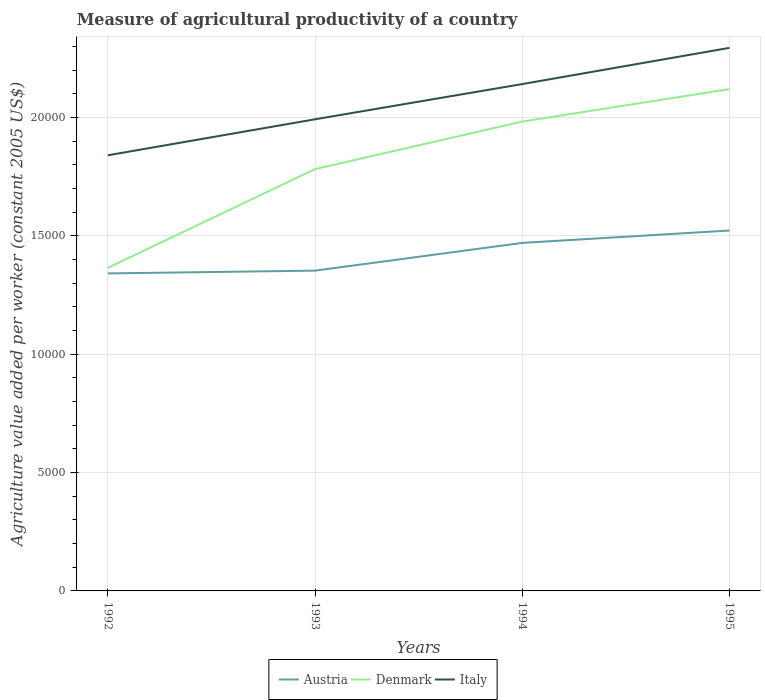Across all years, what is the maximum measure of agricultural productivity in Denmark?
Provide a short and direct response. 1.37e+04. What is the total measure of agricultural productivity in Denmark in the graph?
Provide a short and direct response. -7550.25. What is the difference between the highest and the second highest measure of agricultural productivity in Austria?
Your answer should be very brief. 1812.25. Is the measure of agricultural productivity in Italy strictly greater than the measure of agricultural productivity in Denmark over the years?
Make the answer very short. No. What is the difference between two consecutive major ticks on the Y-axis?
Provide a short and direct response. 5000. Are the values on the major ticks of Y-axis written in scientific E-notation?
Your answer should be compact. No. What is the title of the graph?
Provide a short and direct response. Measure of agricultural productivity of a country. Does "St. Vincent and the Grenadines" appear as one of the legend labels in the graph?
Your answer should be compact. No. What is the label or title of the Y-axis?
Your response must be concise. Agriculture value added per worker (constant 2005 US$). What is the Agriculture value added per worker (constant 2005 US$) of Austria in 1992?
Give a very brief answer. 1.34e+04. What is the Agriculture value added per worker (constant 2005 US$) in Denmark in 1992?
Make the answer very short. 1.37e+04. What is the Agriculture value added per worker (constant 2005 US$) in Italy in 1992?
Make the answer very short. 1.84e+04. What is the Agriculture value added per worker (constant 2005 US$) of Austria in 1993?
Offer a terse response. 1.35e+04. What is the Agriculture value added per worker (constant 2005 US$) in Denmark in 1993?
Ensure brevity in your answer.  1.78e+04. What is the Agriculture value added per worker (constant 2005 US$) of Italy in 1993?
Keep it short and to the point. 1.99e+04. What is the Agriculture value added per worker (constant 2005 US$) in Austria in 1994?
Your answer should be very brief. 1.47e+04. What is the Agriculture value added per worker (constant 2005 US$) of Denmark in 1994?
Your answer should be compact. 1.98e+04. What is the Agriculture value added per worker (constant 2005 US$) in Italy in 1994?
Your answer should be compact. 2.14e+04. What is the Agriculture value added per worker (constant 2005 US$) of Austria in 1995?
Make the answer very short. 1.52e+04. What is the Agriculture value added per worker (constant 2005 US$) in Denmark in 1995?
Make the answer very short. 2.12e+04. What is the Agriculture value added per worker (constant 2005 US$) of Italy in 1995?
Give a very brief answer. 2.29e+04. Across all years, what is the maximum Agriculture value added per worker (constant 2005 US$) of Austria?
Give a very brief answer. 1.52e+04. Across all years, what is the maximum Agriculture value added per worker (constant 2005 US$) of Denmark?
Your answer should be very brief. 2.12e+04. Across all years, what is the maximum Agriculture value added per worker (constant 2005 US$) in Italy?
Provide a short and direct response. 2.29e+04. Across all years, what is the minimum Agriculture value added per worker (constant 2005 US$) in Austria?
Your answer should be compact. 1.34e+04. Across all years, what is the minimum Agriculture value added per worker (constant 2005 US$) in Denmark?
Your answer should be very brief. 1.37e+04. Across all years, what is the minimum Agriculture value added per worker (constant 2005 US$) of Italy?
Ensure brevity in your answer.  1.84e+04. What is the total Agriculture value added per worker (constant 2005 US$) of Austria in the graph?
Keep it short and to the point. 5.69e+04. What is the total Agriculture value added per worker (constant 2005 US$) of Denmark in the graph?
Provide a succinct answer. 7.25e+04. What is the total Agriculture value added per worker (constant 2005 US$) in Italy in the graph?
Make the answer very short. 8.27e+04. What is the difference between the Agriculture value added per worker (constant 2005 US$) in Austria in 1992 and that in 1993?
Offer a very short reply. -117.39. What is the difference between the Agriculture value added per worker (constant 2005 US$) of Denmark in 1992 and that in 1993?
Offer a terse response. -4170.25. What is the difference between the Agriculture value added per worker (constant 2005 US$) in Italy in 1992 and that in 1993?
Provide a succinct answer. -1521.49. What is the difference between the Agriculture value added per worker (constant 2005 US$) of Austria in 1992 and that in 1994?
Your response must be concise. -1288.85. What is the difference between the Agriculture value added per worker (constant 2005 US$) in Denmark in 1992 and that in 1994?
Your answer should be very brief. -6179.53. What is the difference between the Agriculture value added per worker (constant 2005 US$) in Italy in 1992 and that in 1994?
Ensure brevity in your answer.  -3008.88. What is the difference between the Agriculture value added per worker (constant 2005 US$) of Austria in 1992 and that in 1995?
Offer a very short reply. -1812.25. What is the difference between the Agriculture value added per worker (constant 2005 US$) in Denmark in 1992 and that in 1995?
Your answer should be compact. -7550.25. What is the difference between the Agriculture value added per worker (constant 2005 US$) of Italy in 1992 and that in 1995?
Give a very brief answer. -4539.28. What is the difference between the Agriculture value added per worker (constant 2005 US$) of Austria in 1993 and that in 1994?
Your answer should be very brief. -1171.46. What is the difference between the Agriculture value added per worker (constant 2005 US$) in Denmark in 1993 and that in 1994?
Your response must be concise. -2009.28. What is the difference between the Agriculture value added per worker (constant 2005 US$) of Italy in 1993 and that in 1994?
Offer a terse response. -1487.39. What is the difference between the Agriculture value added per worker (constant 2005 US$) of Austria in 1993 and that in 1995?
Your answer should be very brief. -1694.85. What is the difference between the Agriculture value added per worker (constant 2005 US$) in Denmark in 1993 and that in 1995?
Your answer should be very brief. -3380. What is the difference between the Agriculture value added per worker (constant 2005 US$) of Italy in 1993 and that in 1995?
Ensure brevity in your answer.  -3017.79. What is the difference between the Agriculture value added per worker (constant 2005 US$) of Austria in 1994 and that in 1995?
Your answer should be compact. -523.4. What is the difference between the Agriculture value added per worker (constant 2005 US$) of Denmark in 1994 and that in 1995?
Your answer should be very brief. -1370.72. What is the difference between the Agriculture value added per worker (constant 2005 US$) of Italy in 1994 and that in 1995?
Offer a terse response. -1530.4. What is the difference between the Agriculture value added per worker (constant 2005 US$) of Austria in 1992 and the Agriculture value added per worker (constant 2005 US$) of Denmark in 1993?
Your answer should be compact. -4406.2. What is the difference between the Agriculture value added per worker (constant 2005 US$) in Austria in 1992 and the Agriculture value added per worker (constant 2005 US$) in Italy in 1993?
Your response must be concise. -6511.72. What is the difference between the Agriculture value added per worker (constant 2005 US$) of Denmark in 1992 and the Agriculture value added per worker (constant 2005 US$) of Italy in 1993?
Provide a short and direct response. -6275.76. What is the difference between the Agriculture value added per worker (constant 2005 US$) of Austria in 1992 and the Agriculture value added per worker (constant 2005 US$) of Denmark in 1994?
Give a very brief answer. -6415.49. What is the difference between the Agriculture value added per worker (constant 2005 US$) in Austria in 1992 and the Agriculture value added per worker (constant 2005 US$) in Italy in 1994?
Keep it short and to the point. -7999.11. What is the difference between the Agriculture value added per worker (constant 2005 US$) in Denmark in 1992 and the Agriculture value added per worker (constant 2005 US$) in Italy in 1994?
Keep it short and to the point. -7763.15. What is the difference between the Agriculture value added per worker (constant 2005 US$) of Austria in 1992 and the Agriculture value added per worker (constant 2005 US$) of Denmark in 1995?
Your answer should be compact. -7786.2. What is the difference between the Agriculture value added per worker (constant 2005 US$) of Austria in 1992 and the Agriculture value added per worker (constant 2005 US$) of Italy in 1995?
Keep it short and to the point. -9529.51. What is the difference between the Agriculture value added per worker (constant 2005 US$) of Denmark in 1992 and the Agriculture value added per worker (constant 2005 US$) of Italy in 1995?
Your answer should be compact. -9293.56. What is the difference between the Agriculture value added per worker (constant 2005 US$) in Austria in 1993 and the Agriculture value added per worker (constant 2005 US$) in Denmark in 1994?
Your answer should be compact. -6298.09. What is the difference between the Agriculture value added per worker (constant 2005 US$) in Austria in 1993 and the Agriculture value added per worker (constant 2005 US$) in Italy in 1994?
Offer a very short reply. -7881.72. What is the difference between the Agriculture value added per worker (constant 2005 US$) in Denmark in 1993 and the Agriculture value added per worker (constant 2005 US$) in Italy in 1994?
Your answer should be very brief. -3592.91. What is the difference between the Agriculture value added per worker (constant 2005 US$) in Austria in 1993 and the Agriculture value added per worker (constant 2005 US$) in Denmark in 1995?
Offer a very short reply. -7668.81. What is the difference between the Agriculture value added per worker (constant 2005 US$) in Austria in 1993 and the Agriculture value added per worker (constant 2005 US$) in Italy in 1995?
Provide a short and direct response. -9412.12. What is the difference between the Agriculture value added per worker (constant 2005 US$) of Denmark in 1993 and the Agriculture value added per worker (constant 2005 US$) of Italy in 1995?
Ensure brevity in your answer.  -5123.31. What is the difference between the Agriculture value added per worker (constant 2005 US$) in Austria in 1994 and the Agriculture value added per worker (constant 2005 US$) in Denmark in 1995?
Your response must be concise. -6497.35. What is the difference between the Agriculture value added per worker (constant 2005 US$) of Austria in 1994 and the Agriculture value added per worker (constant 2005 US$) of Italy in 1995?
Your response must be concise. -8240.66. What is the difference between the Agriculture value added per worker (constant 2005 US$) in Denmark in 1994 and the Agriculture value added per worker (constant 2005 US$) in Italy in 1995?
Make the answer very short. -3114.03. What is the average Agriculture value added per worker (constant 2005 US$) of Austria per year?
Give a very brief answer. 1.42e+04. What is the average Agriculture value added per worker (constant 2005 US$) in Denmark per year?
Provide a succinct answer. 1.81e+04. What is the average Agriculture value added per worker (constant 2005 US$) of Italy per year?
Keep it short and to the point. 2.07e+04. In the year 1992, what is the difference between the Agriculture value added per worker (constant 2005 US$) of Austria and Agriculture value added per worker (constant 2005 US$) of Denmark?
Ensure brevity in your answer.  -235.95. In the year 1992, what is the difference between the Agriculture value added per worker (constant 2005 US$) in Austria and Agriculture value added per worker (constant 2005 US$) in Italy?
Offer a very short reply. -4990.23. In the year 1992, what is the difference between the Agriculture value added per worker (constant 2005 US$) in Denmark and Agriculture value added per worker (constant 2005 US$) in Italy?
Your response must be concise. -4754.28. In the year 1993, what is the difference between the Agriculture value added per worker (constant 2005 US$) in Austria and Agriculture value added per worker (constant 2005 US$) in Denmark?
Ensure brevity in your answer.  -4288.81. In the year 1993, what is the difference between the Agriculture value added per worker (constant 2005 US$) in Austria and Agriculture value added per worker (constant 2005 US$) in Italy?
Your response must be concise. -6394.32. In the year 1993, what is the difference between the Agriculture value added per worker (constant 2005 US$) of Denmark and Agriculture value added per worker (constant 2005 US$) of Italy?
Your answer should be very brief. -2105.51. In the year 1994, what is the difference between the Agriculture value added per worker (constant 2005 US$) of Austria and Agriculture value added per worker (constant 2005 US$) of Denmark?
Give a very brief answer. -5126.64. In the year 1994, what is the difference between the Agriculture value added per worker (constant 2005 US$) of Austria and Agriculture value added per worker (constant 2005 US$) of Italy?
Your answer should be very brief. -6710.26. In the year 1994, what is the difference between the Agriculture value added per worker (constant 2005 US$) of Denmark and Agriculture value added per worker (constant 2005 US$) of Italy?
Provide a succinct answer. -1583.62. In the year 1995, what is the difference between the Agriculture value added per worker (constant 2005 US$) in Austria and Agriculture value added per worker (constant 2005 US$) in Denmark?
Ensure brevity in your answer.  -5973.96. In the year 1995, what is the difference between the Agriculture value added per worker (constant 2005 US$) in Austria and Agriculture value added per worker (constant 2005 US$) in Italy?
Your answer should be very brief. -7717.27. In the year 1995, what is the difference between the Agriculture value added per worker (constant 2005 US$) in Denmark and Agriculture value added per worker (constant 2005 US$) in Italy?
Provide a succinct answer. -1743.31. What is the ratio of the Agriculture value added per worker (constant 2005 US$) in Austria in 1992 to that in 1993?
Ensure brevity in your answer.  0.99. What is the ratio of the Agriculture value added per worker (constant 2005 US$) in Denmark in 1992 to that in 1993?
Provide a short and direct response. 0.77. What is the ratio of the Agriculture value added per worker (constant 2005 US$) in Italy in 1992 to that in 1993?
Give a very brief answer. 0.92. What is the ratio of the Agriculture value added per worker (constant 2005 US$) of Austria in 1992 to that in 1994?
Provide a succinct answer. 0.91. What is the ratio of the Agriculture value added per worker (constant 2005 US$) in Denmark in 1992 to that in 1994?
Your answer should be very brief. 0.69. What is the ratio of the Agriculture value added per worker (constant 2005 US$) in Italy in 1992 to that in 1994?
Your answer should be very brief. 0.86. What is the ratio of the Agriculture value added per worker (constant 2005 US$) in Austria in 1992 to that in 1995?
Ensure brevity in your answer.  0.88. What is the ratio of the Agriculture value added per worker (constant 2005 US$) of Denmark in 1992 to that in 1995?
Keep it short and to the point. 0.64. What is the ratio of the Agriculture value added per worker (constant 2005 US$) of Italy in 1992 to that in 1995?
Make the answer very short. 0.8. What is the ratio of the Agriculture value added per worker (constant 2005 US$) in Austria in 1993 to that in 1994?
Your answer should be compact. 0.92. What is the ratio of the Agriculture value added per worker (constant 2005 US$) in Denmark in 1993 to that in 1994?
Give a very brief answer. 0.9. What is the ratio of the Agriculture value added per worker (constant 2005 US$) of Italy in 1993 to that in 1994?
Make the answer very short. 0.93. What is the ratio of the Agriculture value added per worker (constant 2005 US$) of Austria in 1993 to that in 1995?
Provide a short and direct response. 0.89. What is the ratio of the Agriculture value added per worker (constant 2005 US$) of Denmark in 1993 to that in 1995?
Make the answer very short. 0.84. What is the ratio of the Agriculture value added per worker (constant 2005 US$) of Italy in 1993 to that in 1995?
Your response must be concise. 0.87. What is the ratio of the Agriculture value added per worker (constant 2005 US$) in Austria in 1994 to that in 1995?
Make the answer very short. 0.97. What is the ratio of the Agriculture value added per worker (constant 2005 US$) in Denmark in 1994 to that in 1995?
Provide a short and direct response. 0.94. What is the ratio of the Agriculture value added per worker (constant 2005 US$) in Italy in 1994 to that in 1995?
Keep it short and to the point. 0.93. What is the difference between the highest and the second highest Agriculture value added per worker (constant 2005 US$) of Austria?
Give a very brief answer. 523.4. What is the difference between the highest and the second highest Agriculture value added per worker (constant 2005 US$) of Denmark?
Offer a terse response. 1370.72. What is the difference between the highest and the second highest Agriculture value added per worker (constant 2005 US$) of Italy?
Provide a succinct answer. 1530.4. What is the difference between the highest and the lowest Agriculture value added per worker (constant 2005 US$) in Austria?
Provide a short and direct response. 1812.25. What is the difference between the highest and the lowest Agriculture value added per worker (constant 2005 US$) of Denmark?
Ensure brevity in your answer.  7550.25. What is the difference between the highest and the lowest Agriculture value added per worker (constant 2005 US$) in Italy?
Provide a short and direct response. 4539.28. 